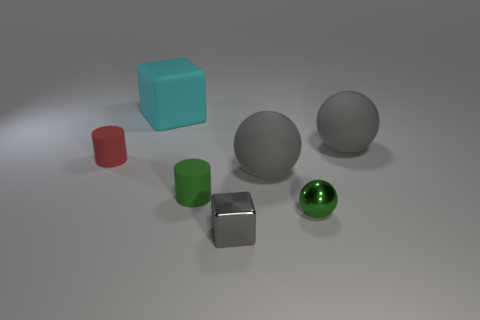How many tiny things have the same color as the tiny shiny sphere?
Keep it short and to the point. 1. What number of objects are either tiny objects that are left of the large cyan block or tiny things behind the green rubber cylinder?
Ensure brevity in your answer.  1. What number of rubber cubes are in front of the large object that is to the left of the gray cube?
Give a very brief answer. 0. What color is the tiny block that is made of the same material as the small green sphere?
Your answer should be very brief. Gray. Are there any rubber spheres that have the same size as the cyan cube?
Offer a terse response. Yes. There is a green matte thing that is the same size as the green metal object; what shape is it?
Your response must be concise. Cylinder. Is there a gray matte thing of the same shape as the green metal object?
Ensure brevity in your answer.  Yes. Is the small red object made of the same material as the cube that is in front of the small red matte object?
Your response must be concise. No. Are there any rubber balls that have the same color as the tiny block?
Offer a terse response. Yes. How many other things are there of the same material as the red cylinder?
Your response must be concise. 4. 